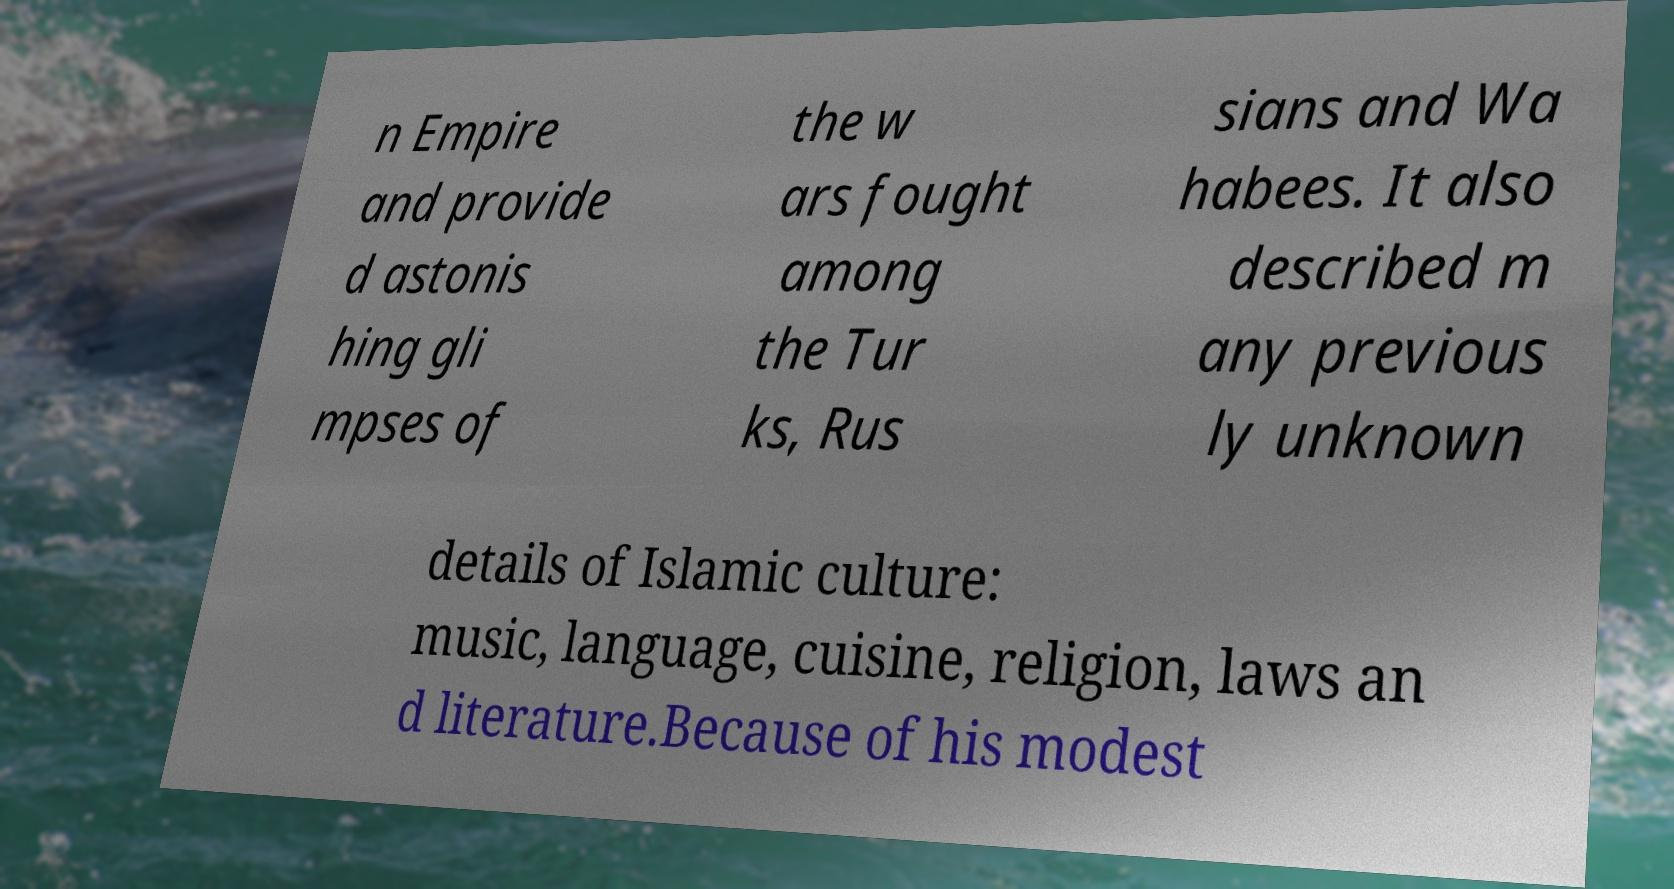Please read and relay the text visible in this image. What does it say? n Empire and provide d astonis hing gli mpses of the w ars fought among the Tur ks, Rus sians and Wa habees. It also described m any previous ly unknown details of Islamic culture: music, language, cuisine, religion, laws an d literature.Because of his modest 